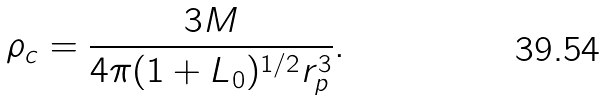<formula> <loc_0><loc_0><loc_500><loc_500>\rho _ { c } = \frac { 3 M } { 4 \pi ( 1 + L _ { 0 } ) ^ { 1 / 2 } r _ { p } ^ { 3 } } .</formula> 